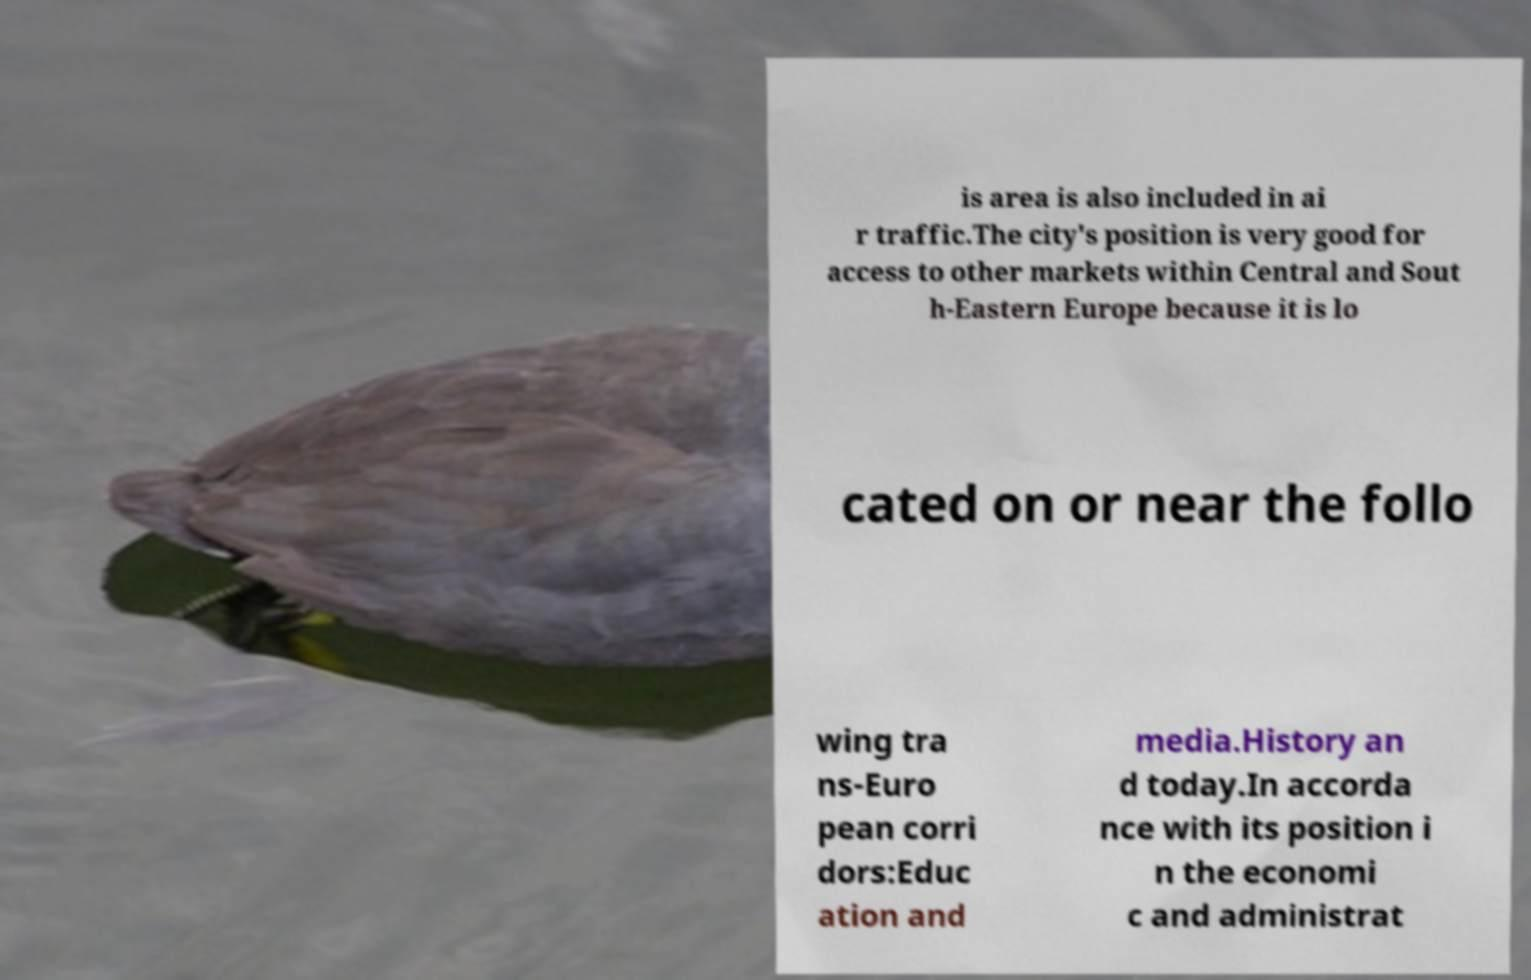What messages or text are displayed in this image? I need them in a readable, typed format. is area is also included in ai r traffic.The city's position is very good for access to other markets within Central and Sout h-Eastern Europe because it is lo cated on or near the follo wing tra ns-Euro pean corri dors:Educ ation and media.History an d today.In accorda nce with its position i n the economi c and administrat 